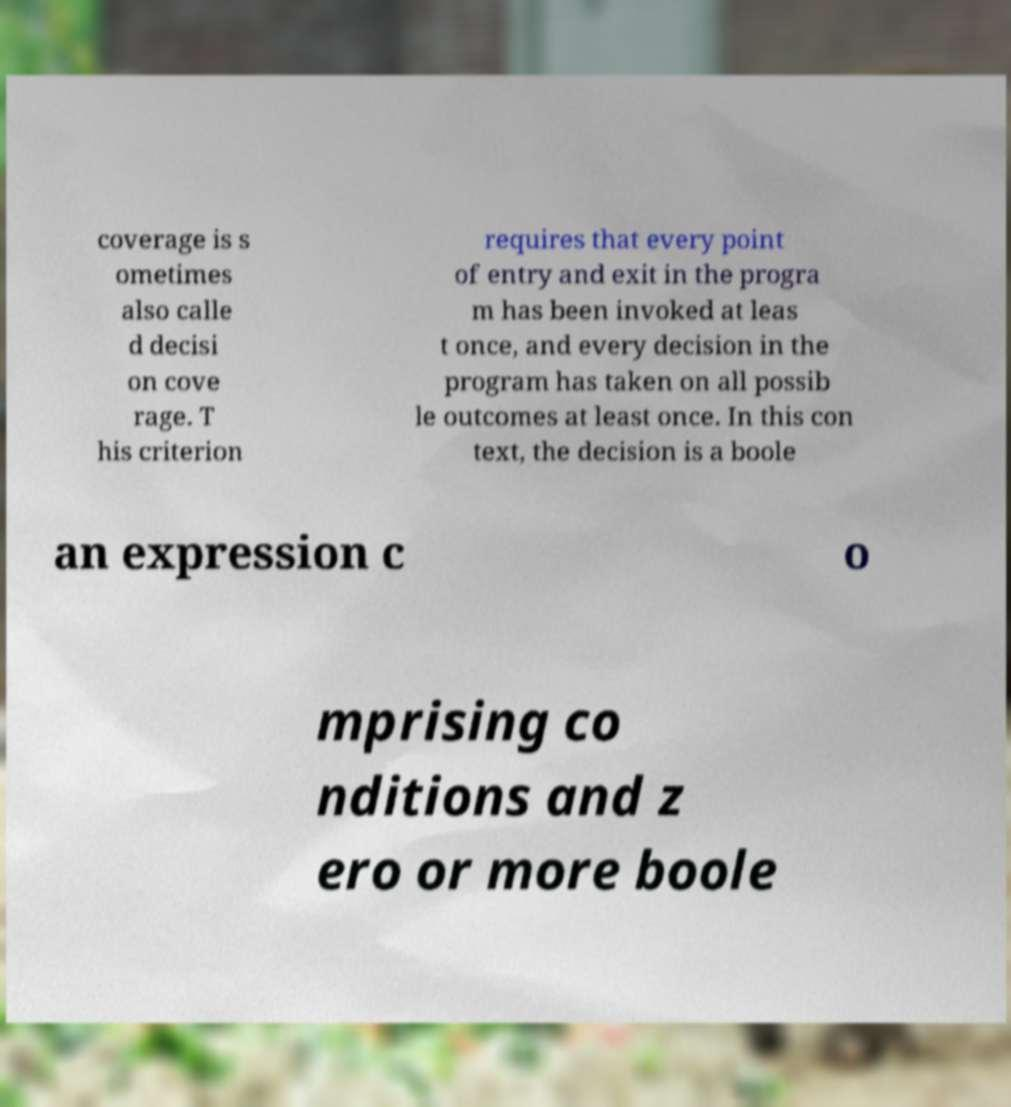Please read and relay the text visible in this image. What does it say? coverage is s ometimes also calle d decisi on cove rage. T his criterion requires that every point of entry and exit in the progra m has been invoked at leas t once, and every decision in the program has taken on all possib le outcomes at least once. In this con text, the decision is a boole an expression c o mprising co nditions and z ero or more boole 